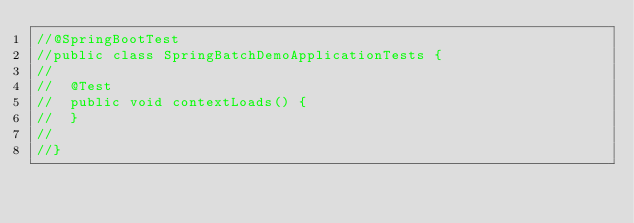Convert code to text. <code><loc_0><loc_0><loc_500><loc_500><_Java_>//@SpringBootTest
//public class SpringBatchDemoApplicationTests {
//
//	@Test
//	public void contextLoads() {
//	}
//
//}
</code> 